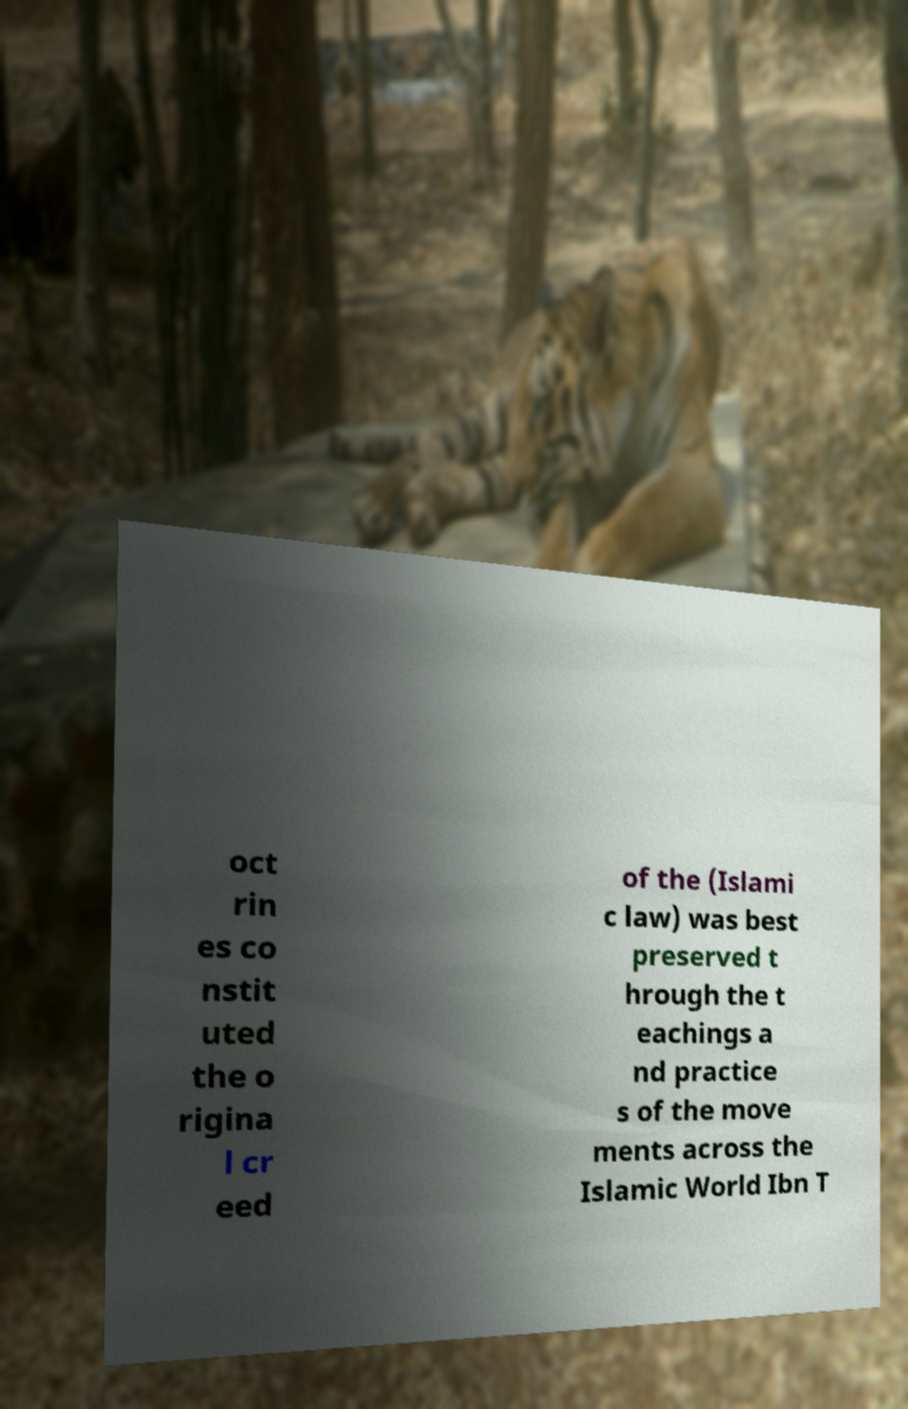Can you read and provide the text displayed in the image?This photo seems to have some interesting text. Can you extract and type it out for me? oct rin es co nstit uted the o rigina l cr eed of the (Islami c law) was best preserved t hrough the t eachings a nd practice s of the move ments across the Islamic World Ibn T 